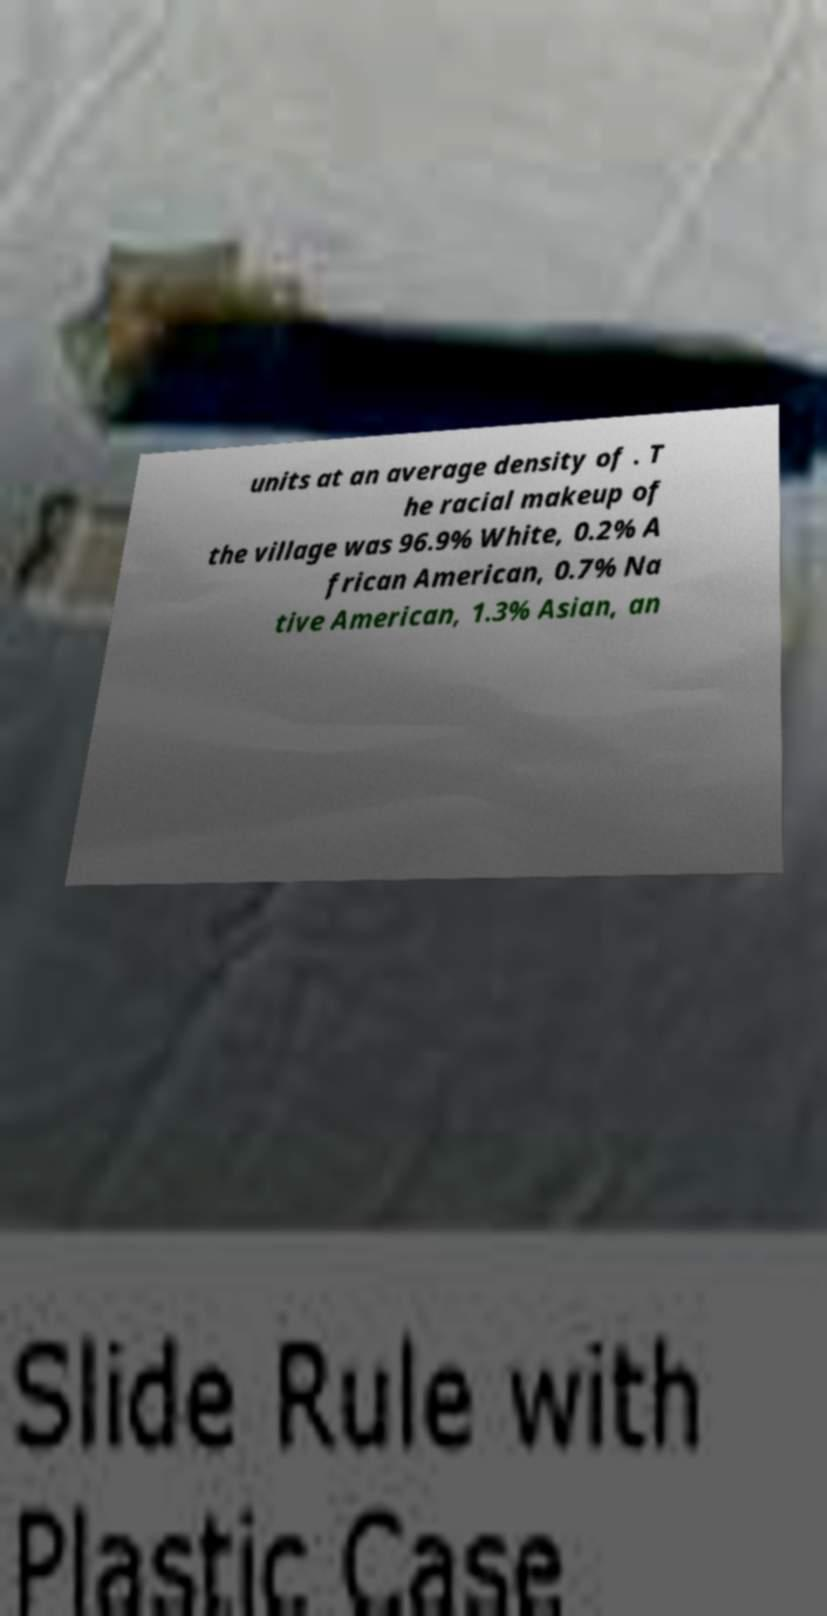Can you accurately transcribe the text from the provided image for me? units at an average density of . T he racial makeup of the village was 96.9% White, 0.2% A frican American, 0.7% Na tive American, 1.3% Asian, an 